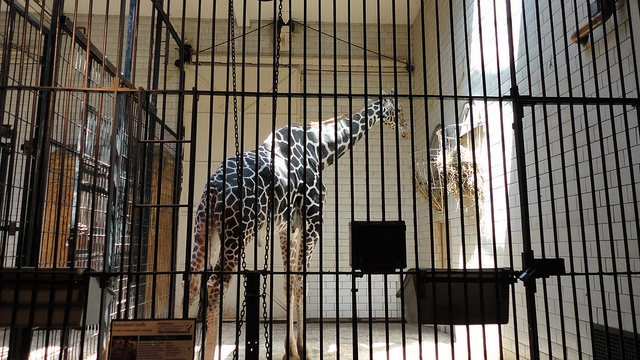Describe the objects in this image and their specific colors. I can see a giraffe in black, gray, and darkgray tones in this image. 